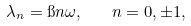Convert formula to latex. <formula><loc_0><loc_0><loc_500><loc_500>\lambda _ { n } = \i n \omega , \quad n = 0 , \pm 1 ,</formula> 